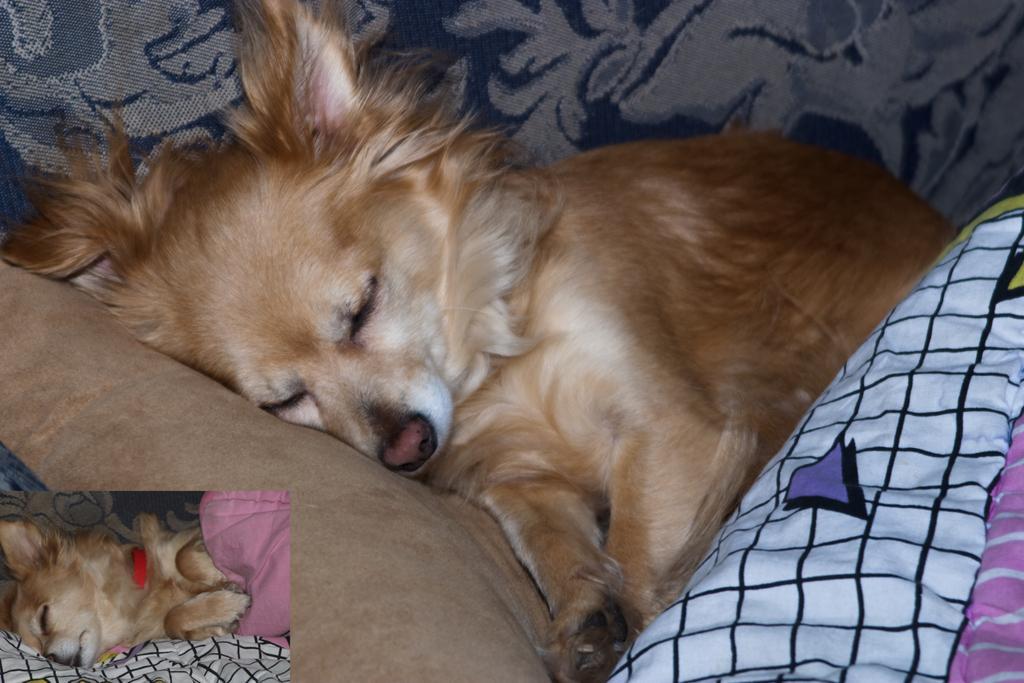Describe this image in one or two sentences. In this image I can see a dog in brown color and the dog is sleeping on the couch. The couch is in blue color, in front I can see few blankets in brown, white and black color. 